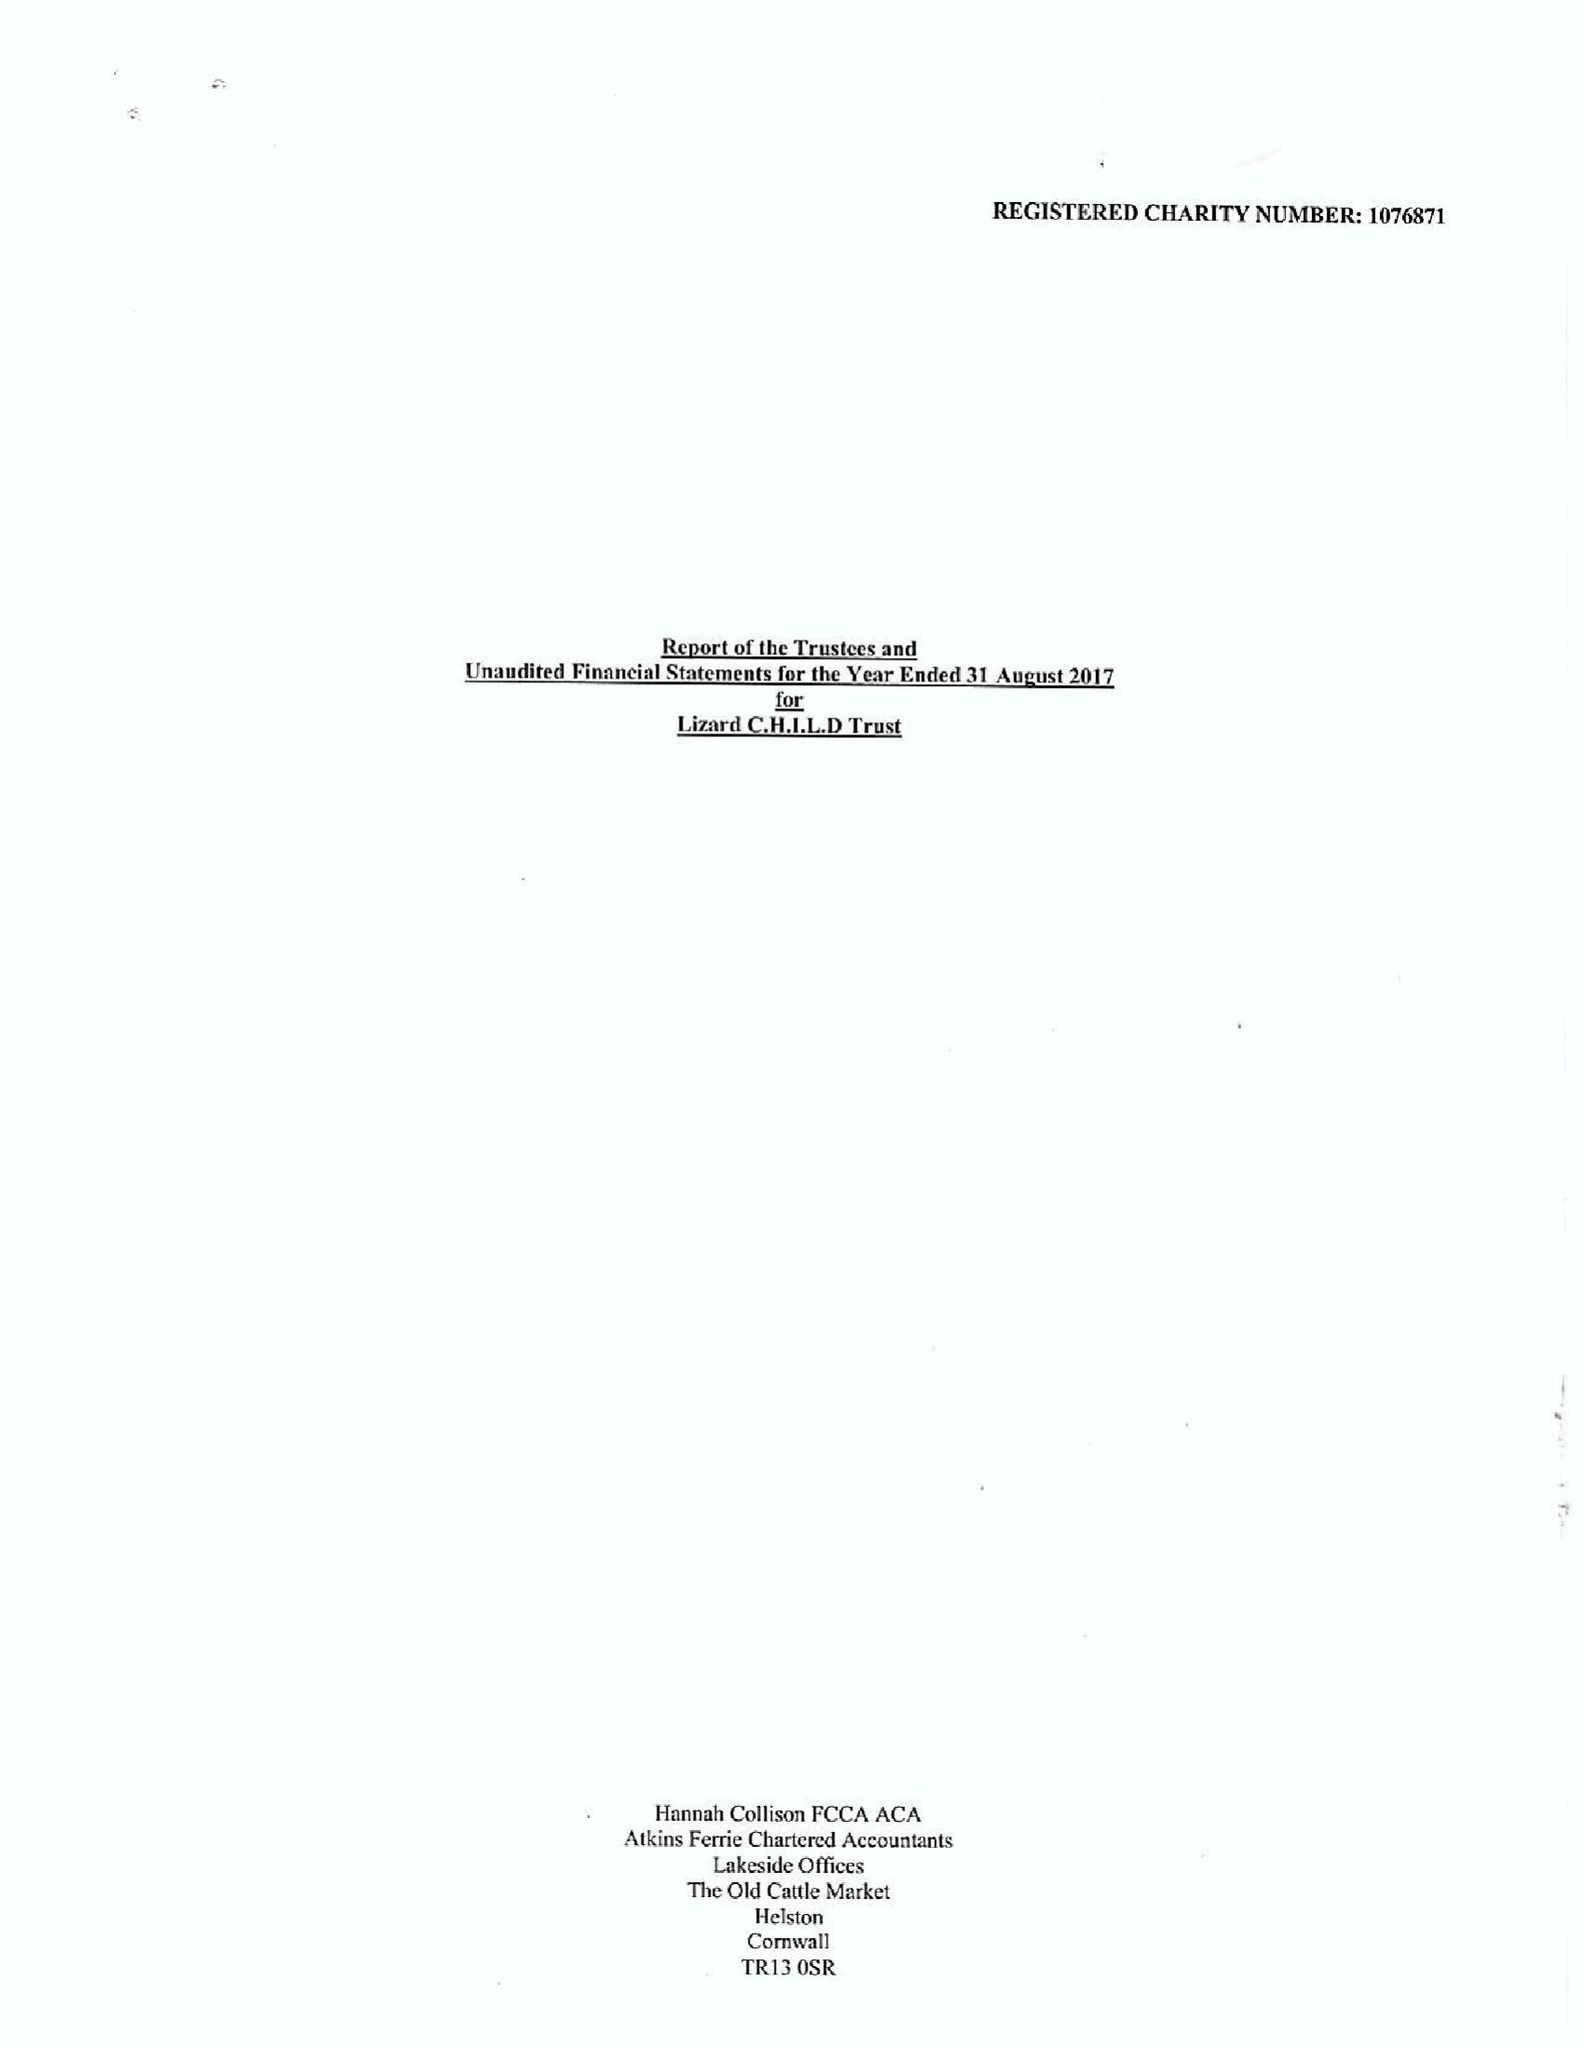What is the value for the income_annually_in_british_pounds?
Answer the question using a single word or phrase. 281434.00 